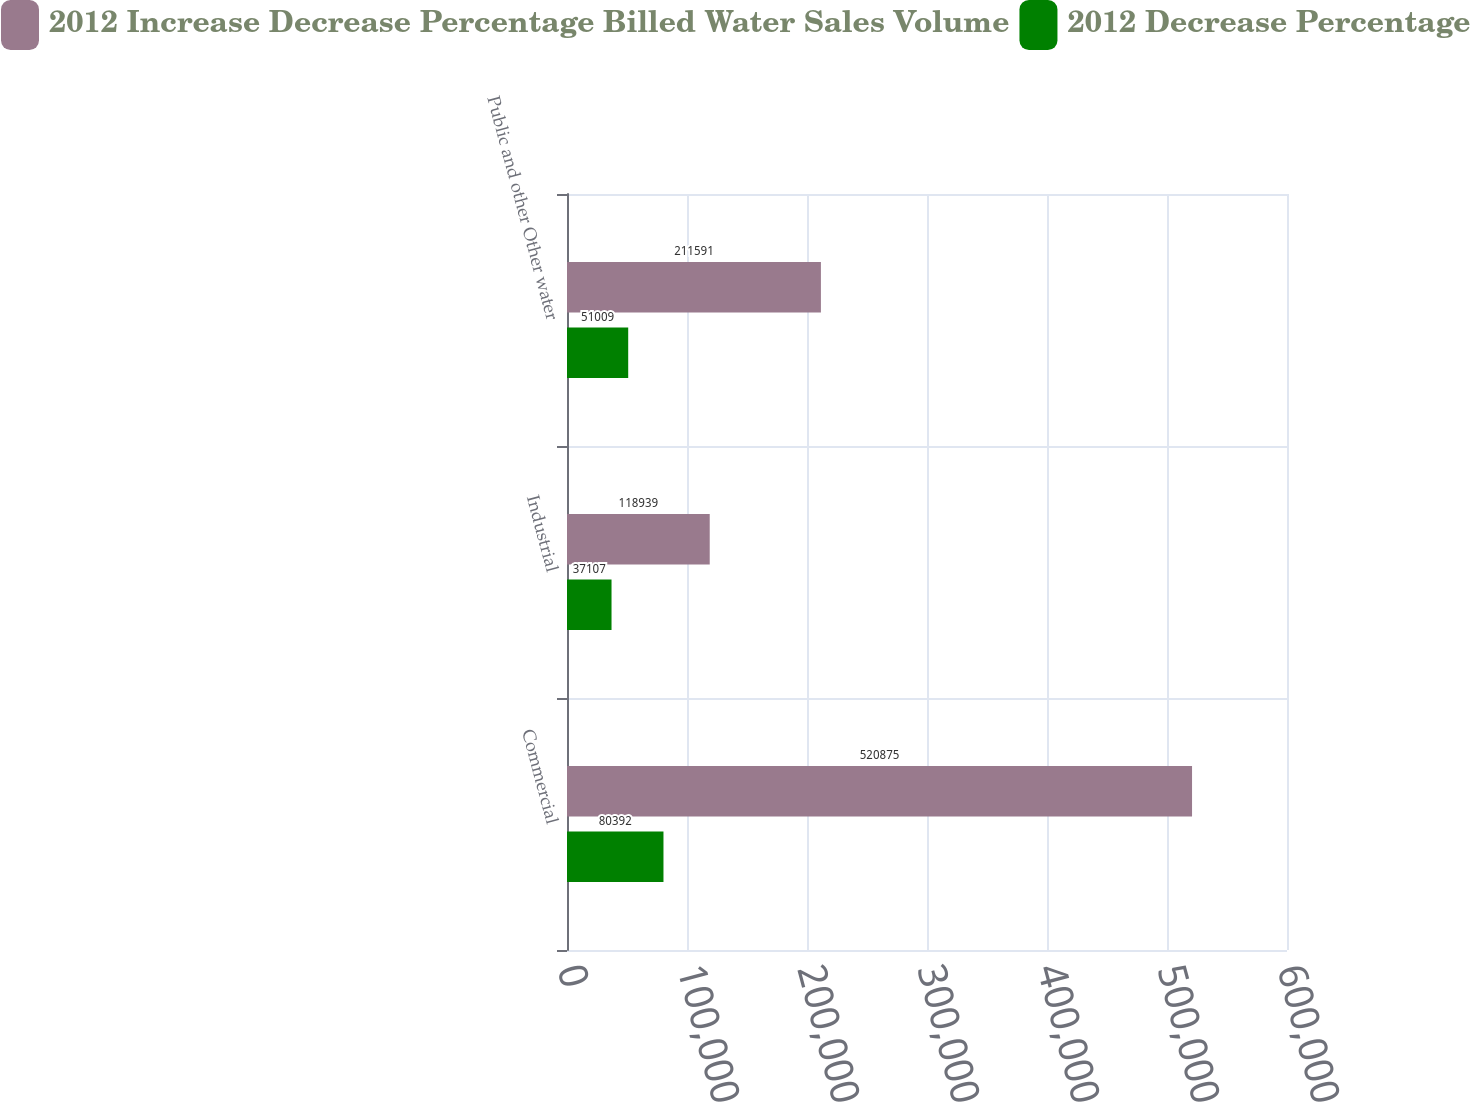Convert chart. <chart><loc_0><loc_0><loc_500><loc_500><stacked_bar_chart><ecel><fcel>Commercial<fcel>Industrial<fcel>Public and other Other water<nl><fcel>2012 Increase Decrease Percentage Billed Water Sales Volume<fcel>520875<fcel>118939<fcel>211591<nl><fcel>2012 Decrease Percentage<fcel>80392<fcel>37107<fcel>51009<nl></chart> 